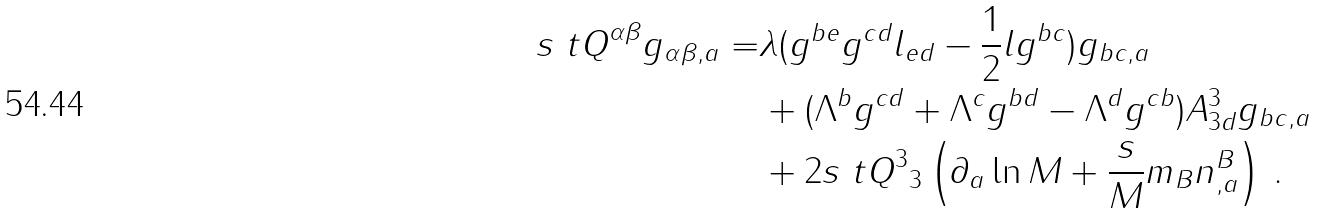Convert formula to latex. <formula><loc_0><loc_0><loc_500><loc_500>s { \ t Q } ^ { \alpha \beta } g _ { \alpha \beta , a } = & \lambda ( g ^ { b e } g ^ { c d } l _ { e d } - \frac { 1 } { 2 } l g ^ { b c } ) g _ { b c , a } \\ & + ( \Lambda ^ { b } g ^ { c d } + \Lambda ^ { c } g ^ { b d } - \Lambda ^ { d } g ^ { c b } ) A ^ { 3 } _ { 3 d } g _ { b c , a } \\ & + 2 s { \ t Q } ^ { 3 } { _ { 3 } } \left ( \partial _ { a } \ln M + \frac { s } M m _ { B } n ^ { B } _ { , a } \right ) \, .</formula> 